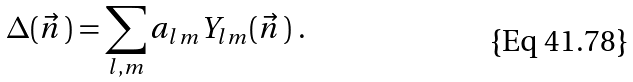Convert formula to latex. <formula><loc_0><loc_0><loc_500><loc_500>\Delta ( \vec { n } \, ) = \sum _ { l , m } a _ { l m } Y _ { l m } ( \vec { n } \, ) \ .</formula> 